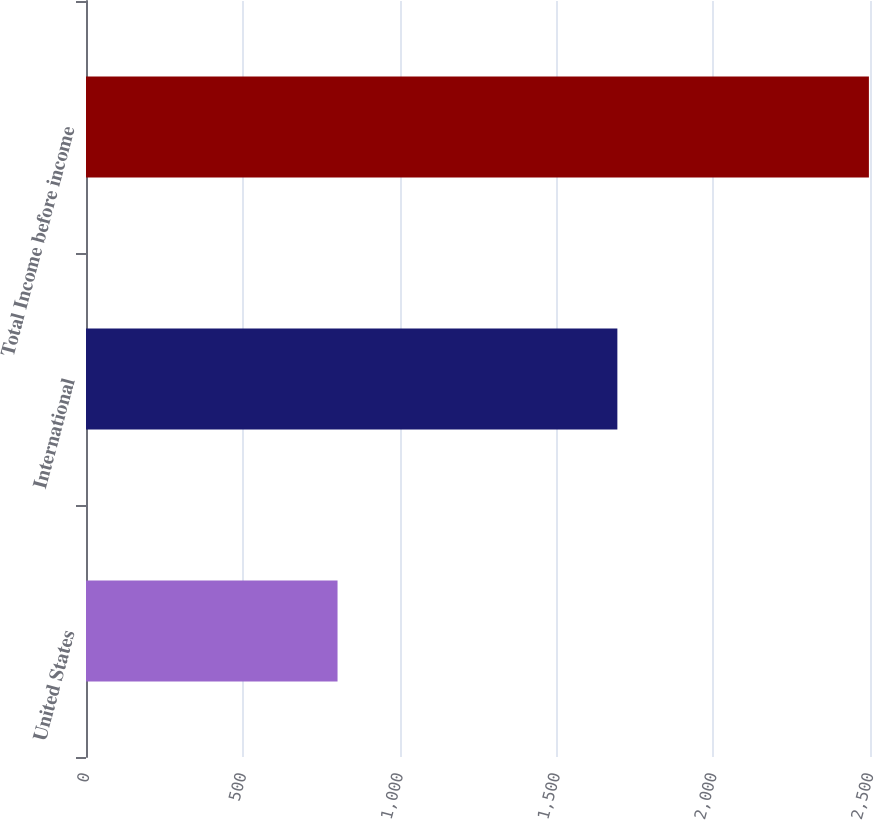<chart> <loc_0><loc_0><loc_500><loc_500><bar_chart><fcel>United States<fcel>International<fcel>Total Income before income<nl><fcel>802.1<fcel>1694.4<fcel>2496.5<nl></chart> 